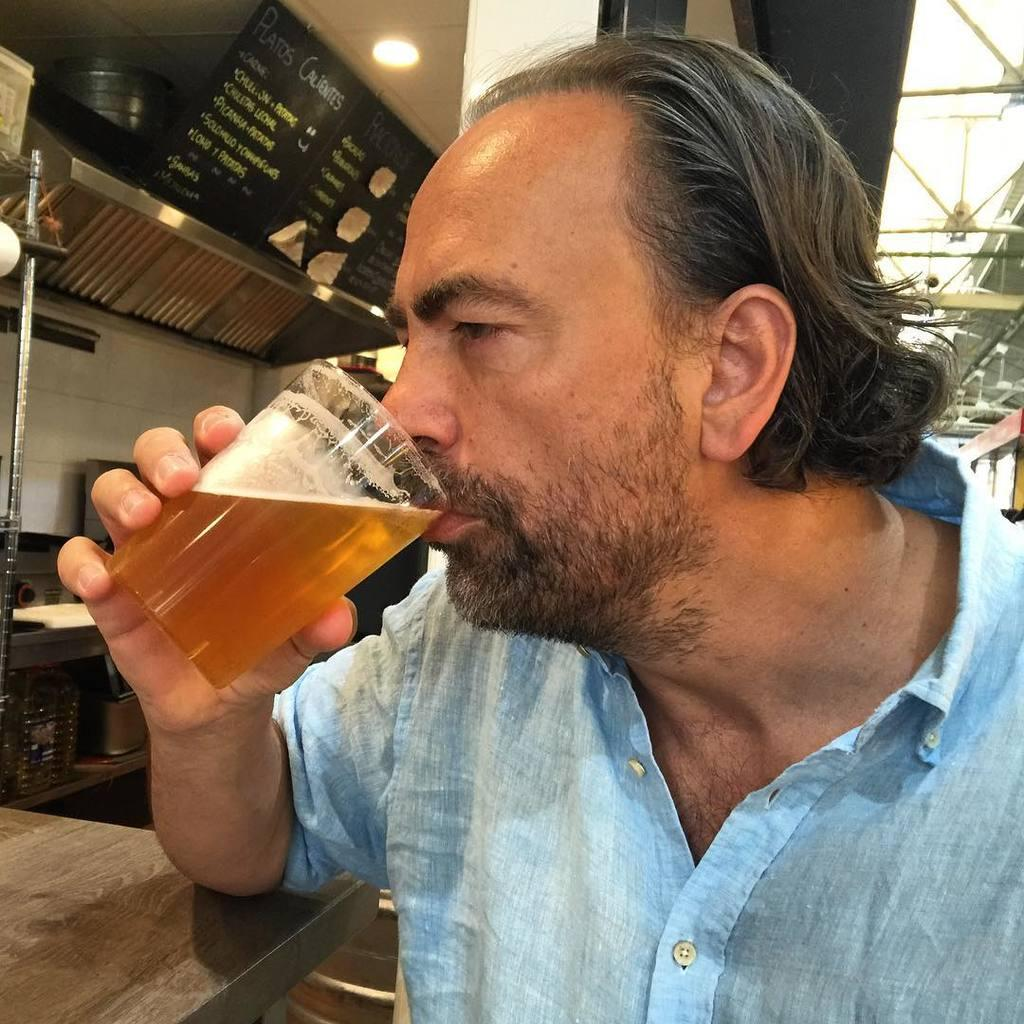Who is present in the image? There is a man in the image. What is the man holding in the image? The man is holding a glass. What is the man doing with the glass? The man is drinking from the glass. What can be seen in the background of the image? There are vessels visible in the background of the image. What type of locket is the man wearing in the image? There is no locket visible on the man in the image. What kind of machine is the man operating in the image? There is no machine present in the image; the man is simply holding a glass and drinking from it. 